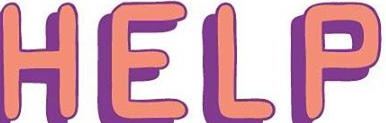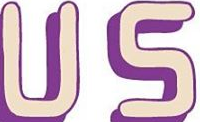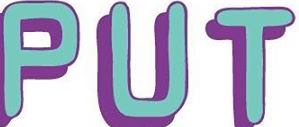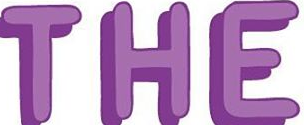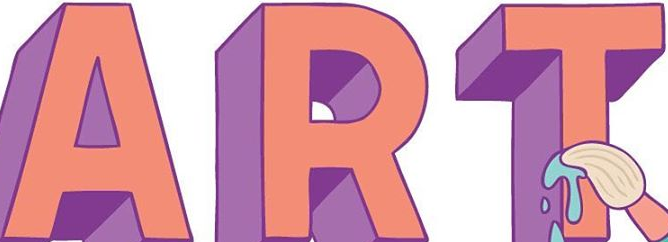Transcribe the words shown in these images in order, separated by a semicolon. HELP; US; PUT; THE; ART 